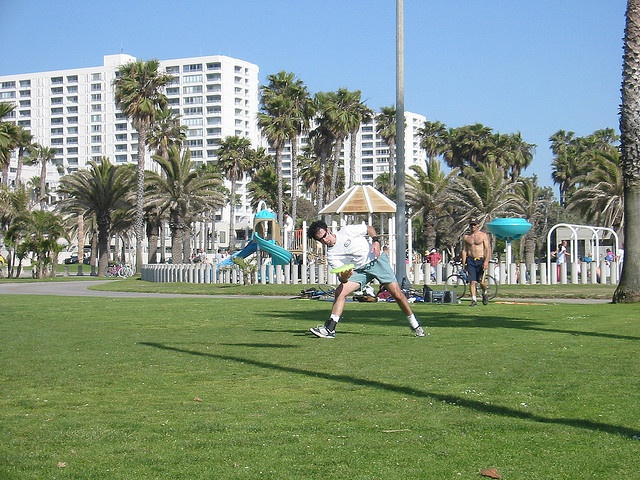Describe the objects in this image and their specific colors. I can see people in darkgray, white, black, and gray tones, people in darkgray, black, tan, and gray tones, bicycle in darkgray, olive, gray, and black tones, bicycle in darkgray, olive, gray, and lightgray tones, and bicycle in darkgray, gray, and lightgray tones in this image. 